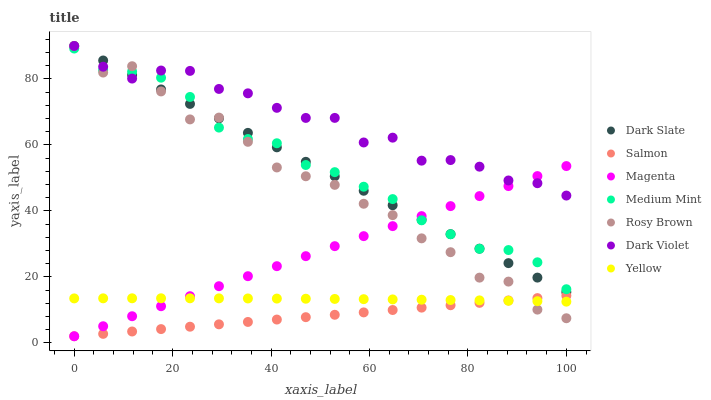Does Salmon have the minimum area under the curve?
Answer yes or no. Yes. Does Dark Violet have the maximum area under the curve?
Answer yes or no. Yes. Does Rosy Brown have the minimum area under the curve?
Answer yes or no. No. Does Rosy Brown have the maximum area under the curve?
Answer yes or no. No. Is Salmon the smoothest?
Answer yes or no. Yes. Is Rosy Brown the roughest?
Answer yes or no. Yes. Is Rosy Brown the smoothest?
Answer yes or no. No. Is Salmon the roughest?
Answer yes or no. No. Does Salmon have the lowest value?
Answer yes or no. Yes. Does Rosy Brown have the lowest value?
Answer yes or no. No. Does Dark Slate have the highest value?
Answer yes or no. Yes. Does Salmon have the highest value?
Answer yes or no. No. Is Yellow less than Dark Slate?
Answer yes or no. Yes. Is Dark Violet greater than Salmon?
Answer yes or no. Yes. Does Salmon intersect Yellow?
Answer yes or no. Yes. Is Salmon less than Yellow?
Answer yes or no. No. Is Salmon greater than Yellow?
Answer yes or no. No. Does Yellow intersect Dark Slate?
Answer yes or no. No. 